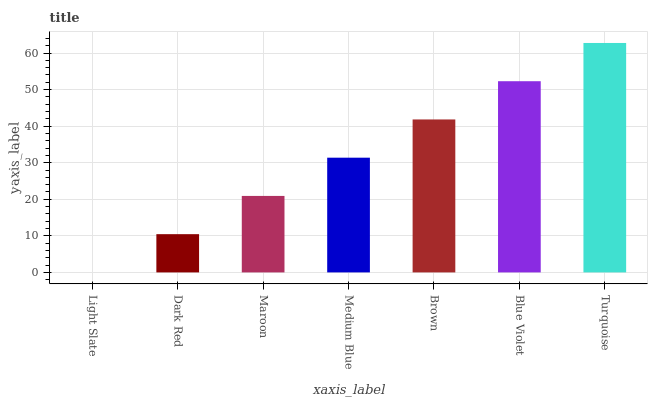Is Dark Red the minimum?
Answer yes or no. No. Is Dark Red the maximum?
Answer yes or no. No. Is Dark Red greater than Light Slate?
Answer yes or no. Yes. Is Light Slate less than Dark Red?
Answer yes or no. Yes. Is Light Slate greater than Dark Red?
Answer yes or no. No. Is Dark Red less than Light Slate?
Answer yes or no. No. Is Medium Blue the high median?
Answer yes or no. Yes. Is Medium Blue the low median?
Answer yes or no. Yes. Is Light Slate the high median?
Answer yes or no. No. Is Light Slate the low median?
Answer yes or no. No. 